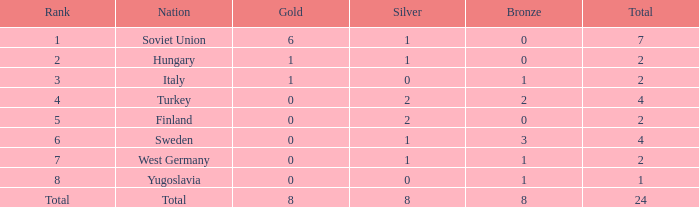What is the total amount when the position is 8, and the number of bronze is below 1? None. 